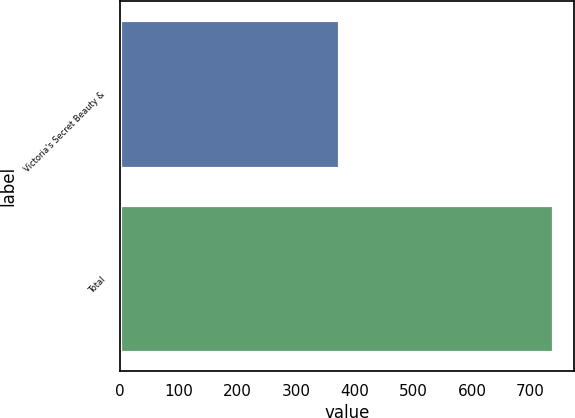Convert chart to OTSL. <chart><loc_0><loc_0><loc_500><loc_500><bar_chart><fcel>Victoria's Secret Beauty &<fcel>Total<nl><fcel>373<fcel>738<nl></chart> 